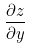Convert formula to latex. <formula><loc_0><loc_0><loc_500><loc_500>\frac { \partial z } { \partial y }</formula> 